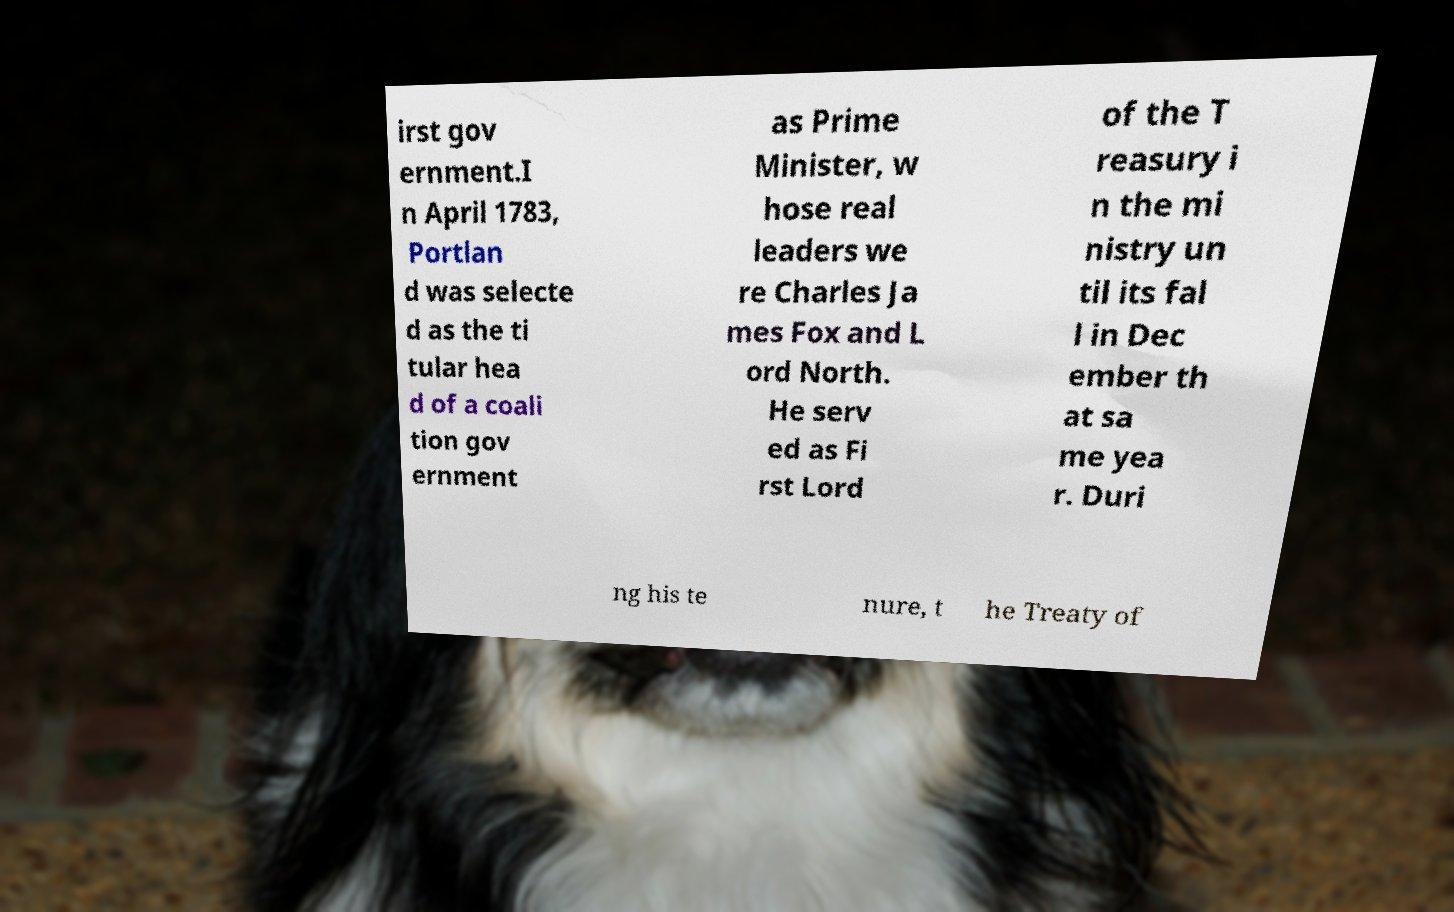Could you assist in decoding the text presented in this image and type it out clearly? irst gov ernment.I n April 1783, Portlan d was selecte d as the ti tular hea d of a coali tion gov ernment as Prime Minister, w hose real leaders we re Charles Ja mes Fox and L ord North. He serv ed as Fi rst Lord of the T reasury i n the mi nistry un til its fal l in Dec ember th at sa me yea r. Duri ng his te nure, t he Treaty of 